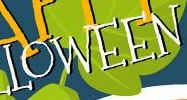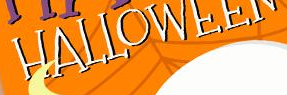Identify the words shown in these images in order, separated by a semicolon. LOWEEN; HALLOWEEN 